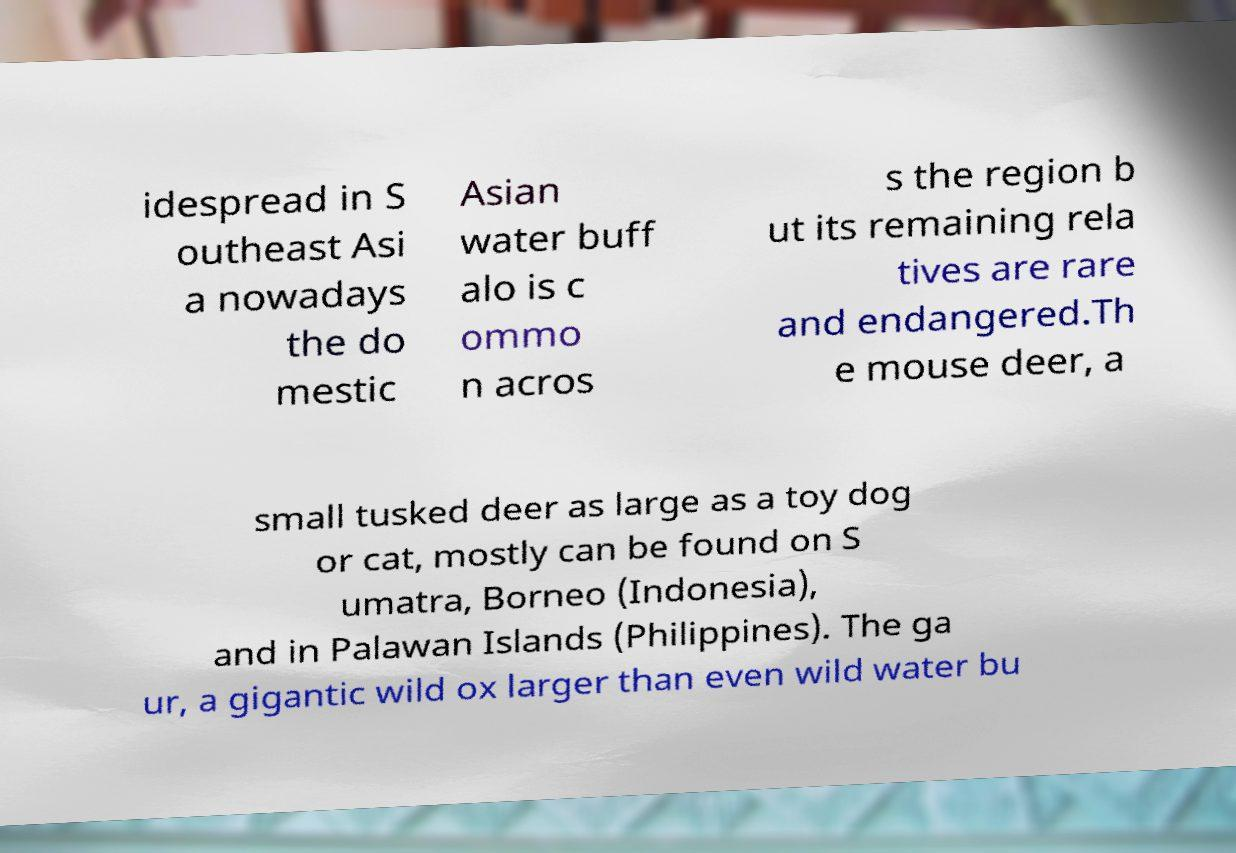Please identify and transcribe the text found in this image. idespread in S outheast Asi a nowadays the do mestic Asian water buff alo is c ommo n acros s the region b ut its remaining rela tives are rare and endangered.Th e mouse deer, a small tusked deer as large as a toy dog or cat, mostly can be found on S umatra, Borneo (Indonesia), and in Palawan Islands (Philippines). The ga ur, a gigantic wild ox larger than even wild water bu 